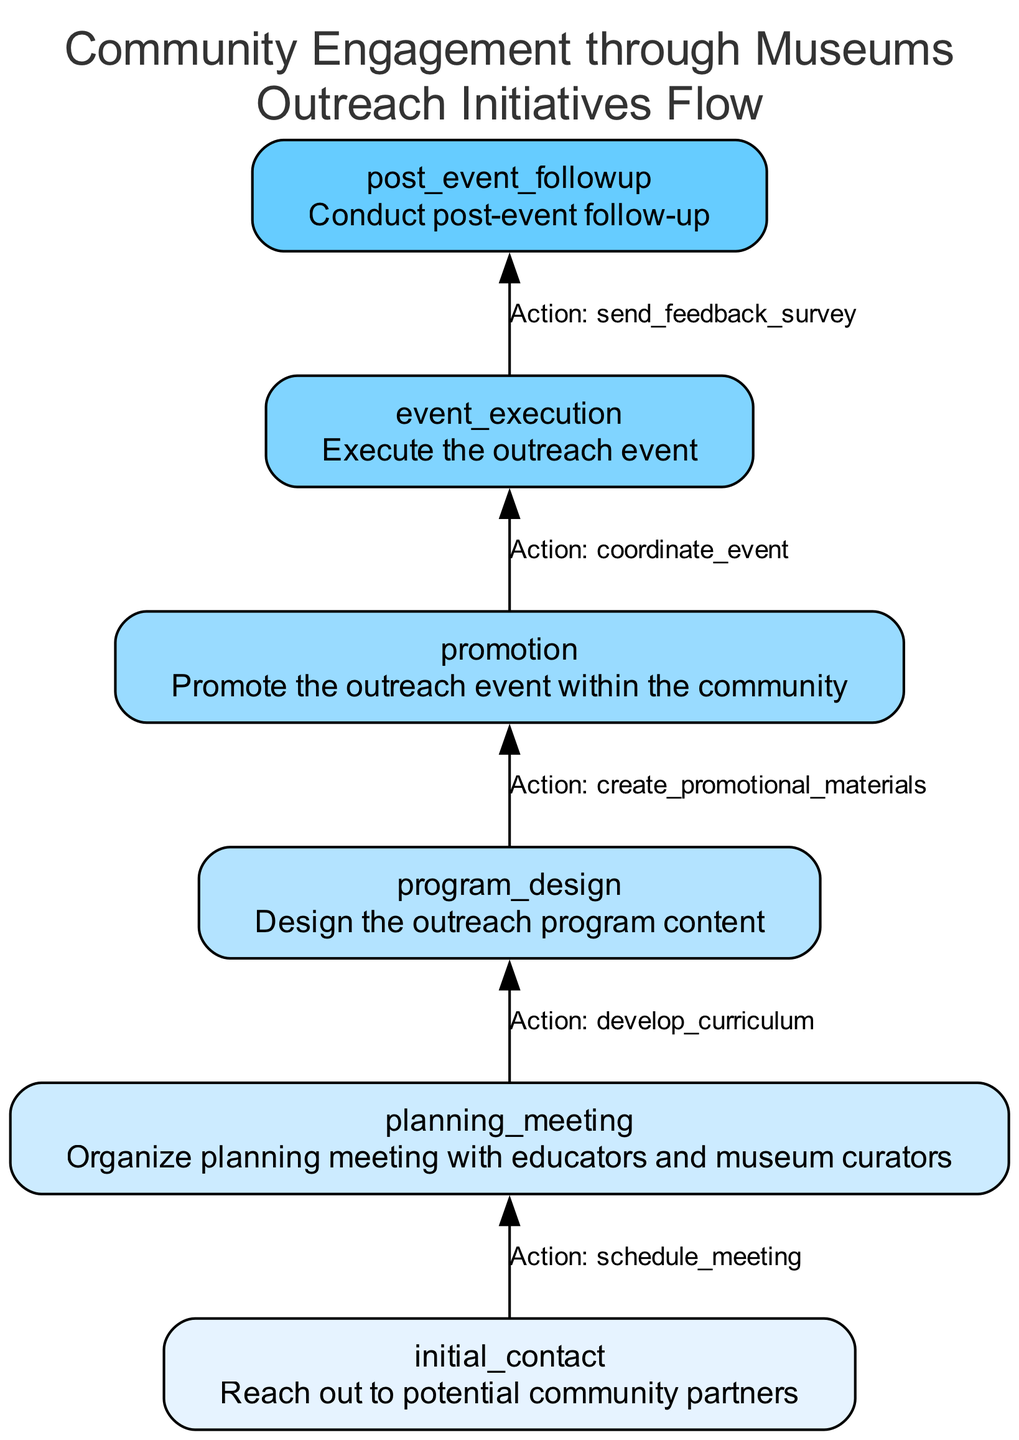What is the first step in the outreach process? The first step is "Reach out to potential community partners", as indicated in the diagram under the "initial_contact" node.
Answer: initial_contact How many dependencies does the "event_execution" step have? The "event_execution" step has one dependency, which is the "promotion" step, pointing to it in the diagram.
Answer: 1 What is the action taken in the "program_design" step? The action taken during the "program_design" step is "develop_curriculum", as specified in the respective node.
Answer: develop_curriculum Which node follows "planning_meeting"? The node that follows "planning_meeting" is "program_design". It is shown that "program_design" depends on the completion of the "planning_meeting".
Answer: program_design What is the last step in the flowchart? The last step in the flowchart is "Conduct post-event follow-up", which is shown at the top of the diagram under the "post_event_followup" node.
Answer: post_event_followup What are the recipients for the feedback survey in the last step? The recipients for the feedback survey in the "post_event_followup" step are "event_attendees", which are listed in the parameters section of that node.
Answer: event_attendees What step must be completed before executing the outreach event? Before executing the outreach event, the "promotion" step must be completed, as indicated by the dependency arrow from "promotion" to "event_execution".
Answer: promotion How many total steps are in the outreach process? The outreach process contains six steps, which are shown as different nodes in the diagram.
Answer: 6 